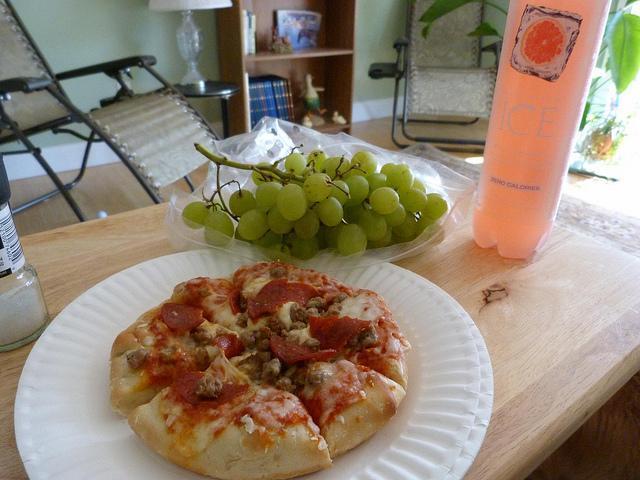Is this affirmation: "The potted plant is far away from the pizza." correct?
Answer yes or no. Yes. 